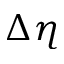<formula> <loc_0><loc_0><loc_500><loc_500>\Delta \eta</formula> 